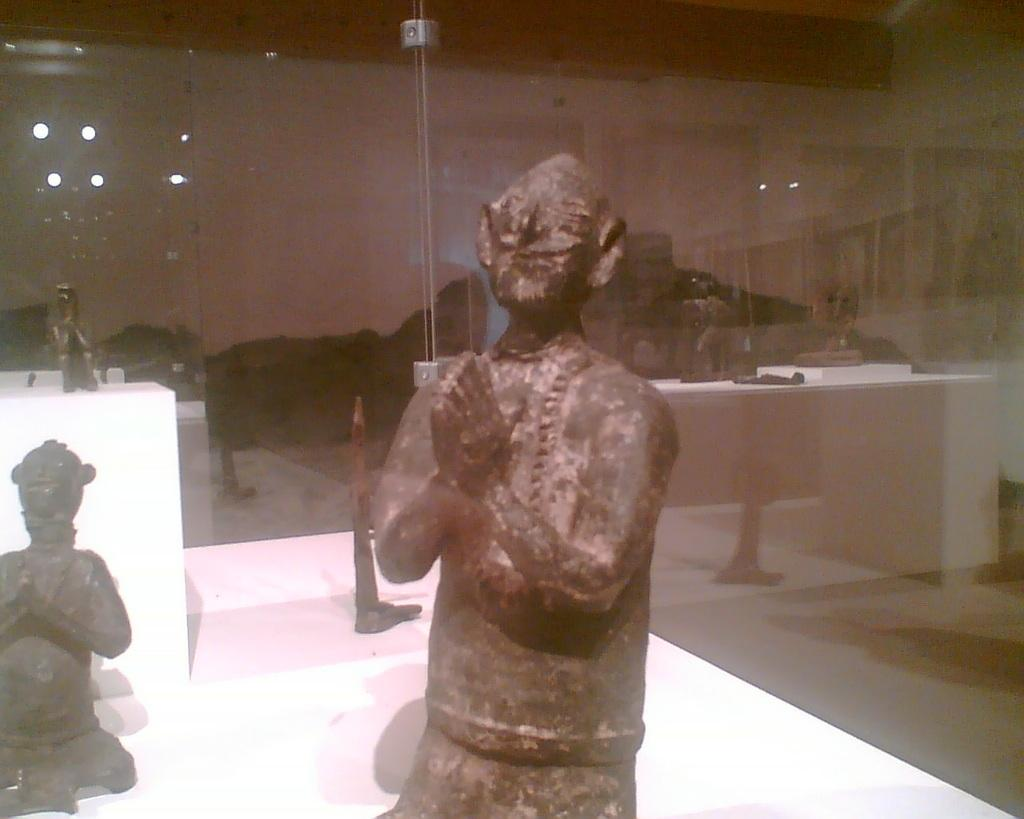What is the main subject of the image? There is a depiction of a person in the center of the image. What can be seen in the background of the image? There is glass in the background of the image. Can you see an orange being peeled by the person in the image? There is no orange or any indication of peeling in the image; it only shows a person in the center and glass in the background. 